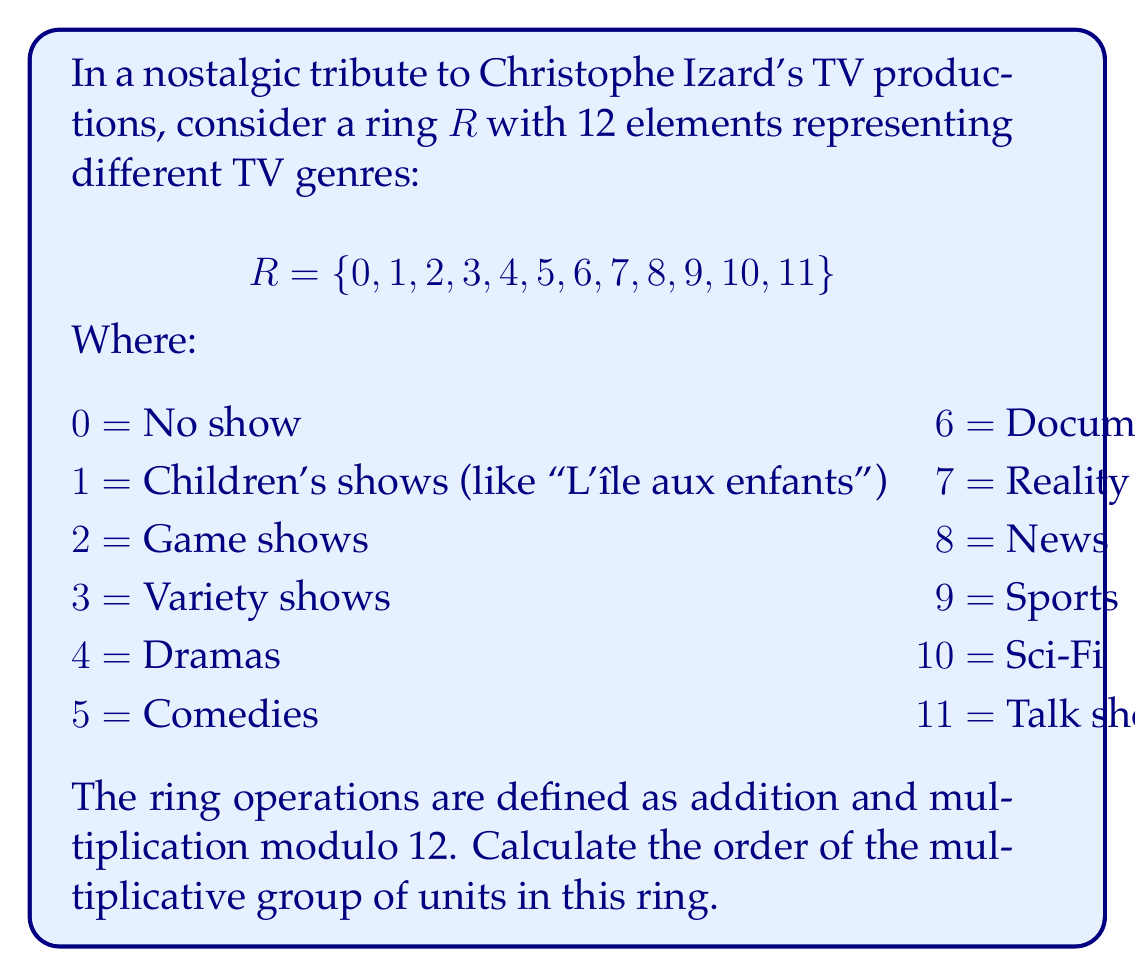What is the answer to this math problem? To find the order of the multiplicative group of units in this ring, we need to follow these steps:

1) First, identify the units in the ring. A unit is an element that has a multiplicative inverse.

2) In a ring with modulo 12 multiplication, an element is a unit if and only if it is coprime to 12.

3) The elements coprime to 12 are: 1, 5, 7, 11

4) Let's verify:
   $1 \cdot 1 \equiv 1 \pmod{12}$
   $5 \cdot 5 \equiv 1 \pmod{12}$
   $7 \cdot 7 \equiv 1 \pmod{12}$
   $11 \cdot 11 \equiv 1 \pmod{12}$

5) The multiplicative group of units is thus $U(R) = \{1, 5, 7, 11\}$

6) The order of a group is the number of elements in the group.

7) Therefore, the order of $U(R)$ is 4.

This result tells us that there are 4 TV genres in our ring that have multiplicative inverses, which could be interpreted as genres that can be combined or transformed into any other genre through some creative process.
Answer: 4 